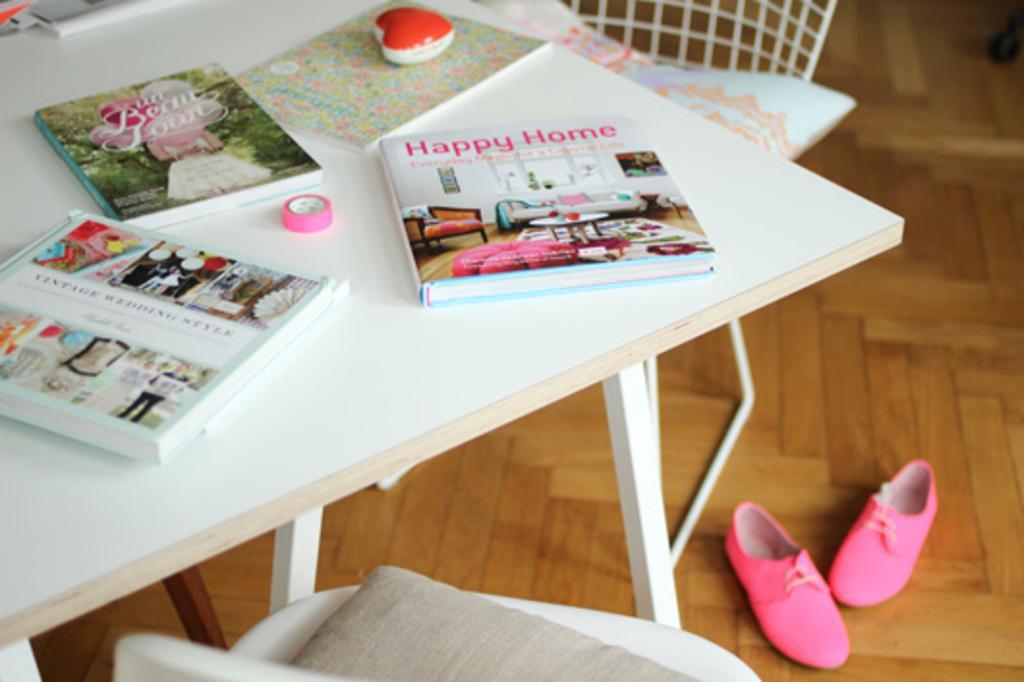Please provide a concise description of this image. In this picture, we see a white table on which the books, red color object and a pink tape are placed. At the bottom, we see a chair, pink shoes and the wooden floor. At the top, we see a chair. 